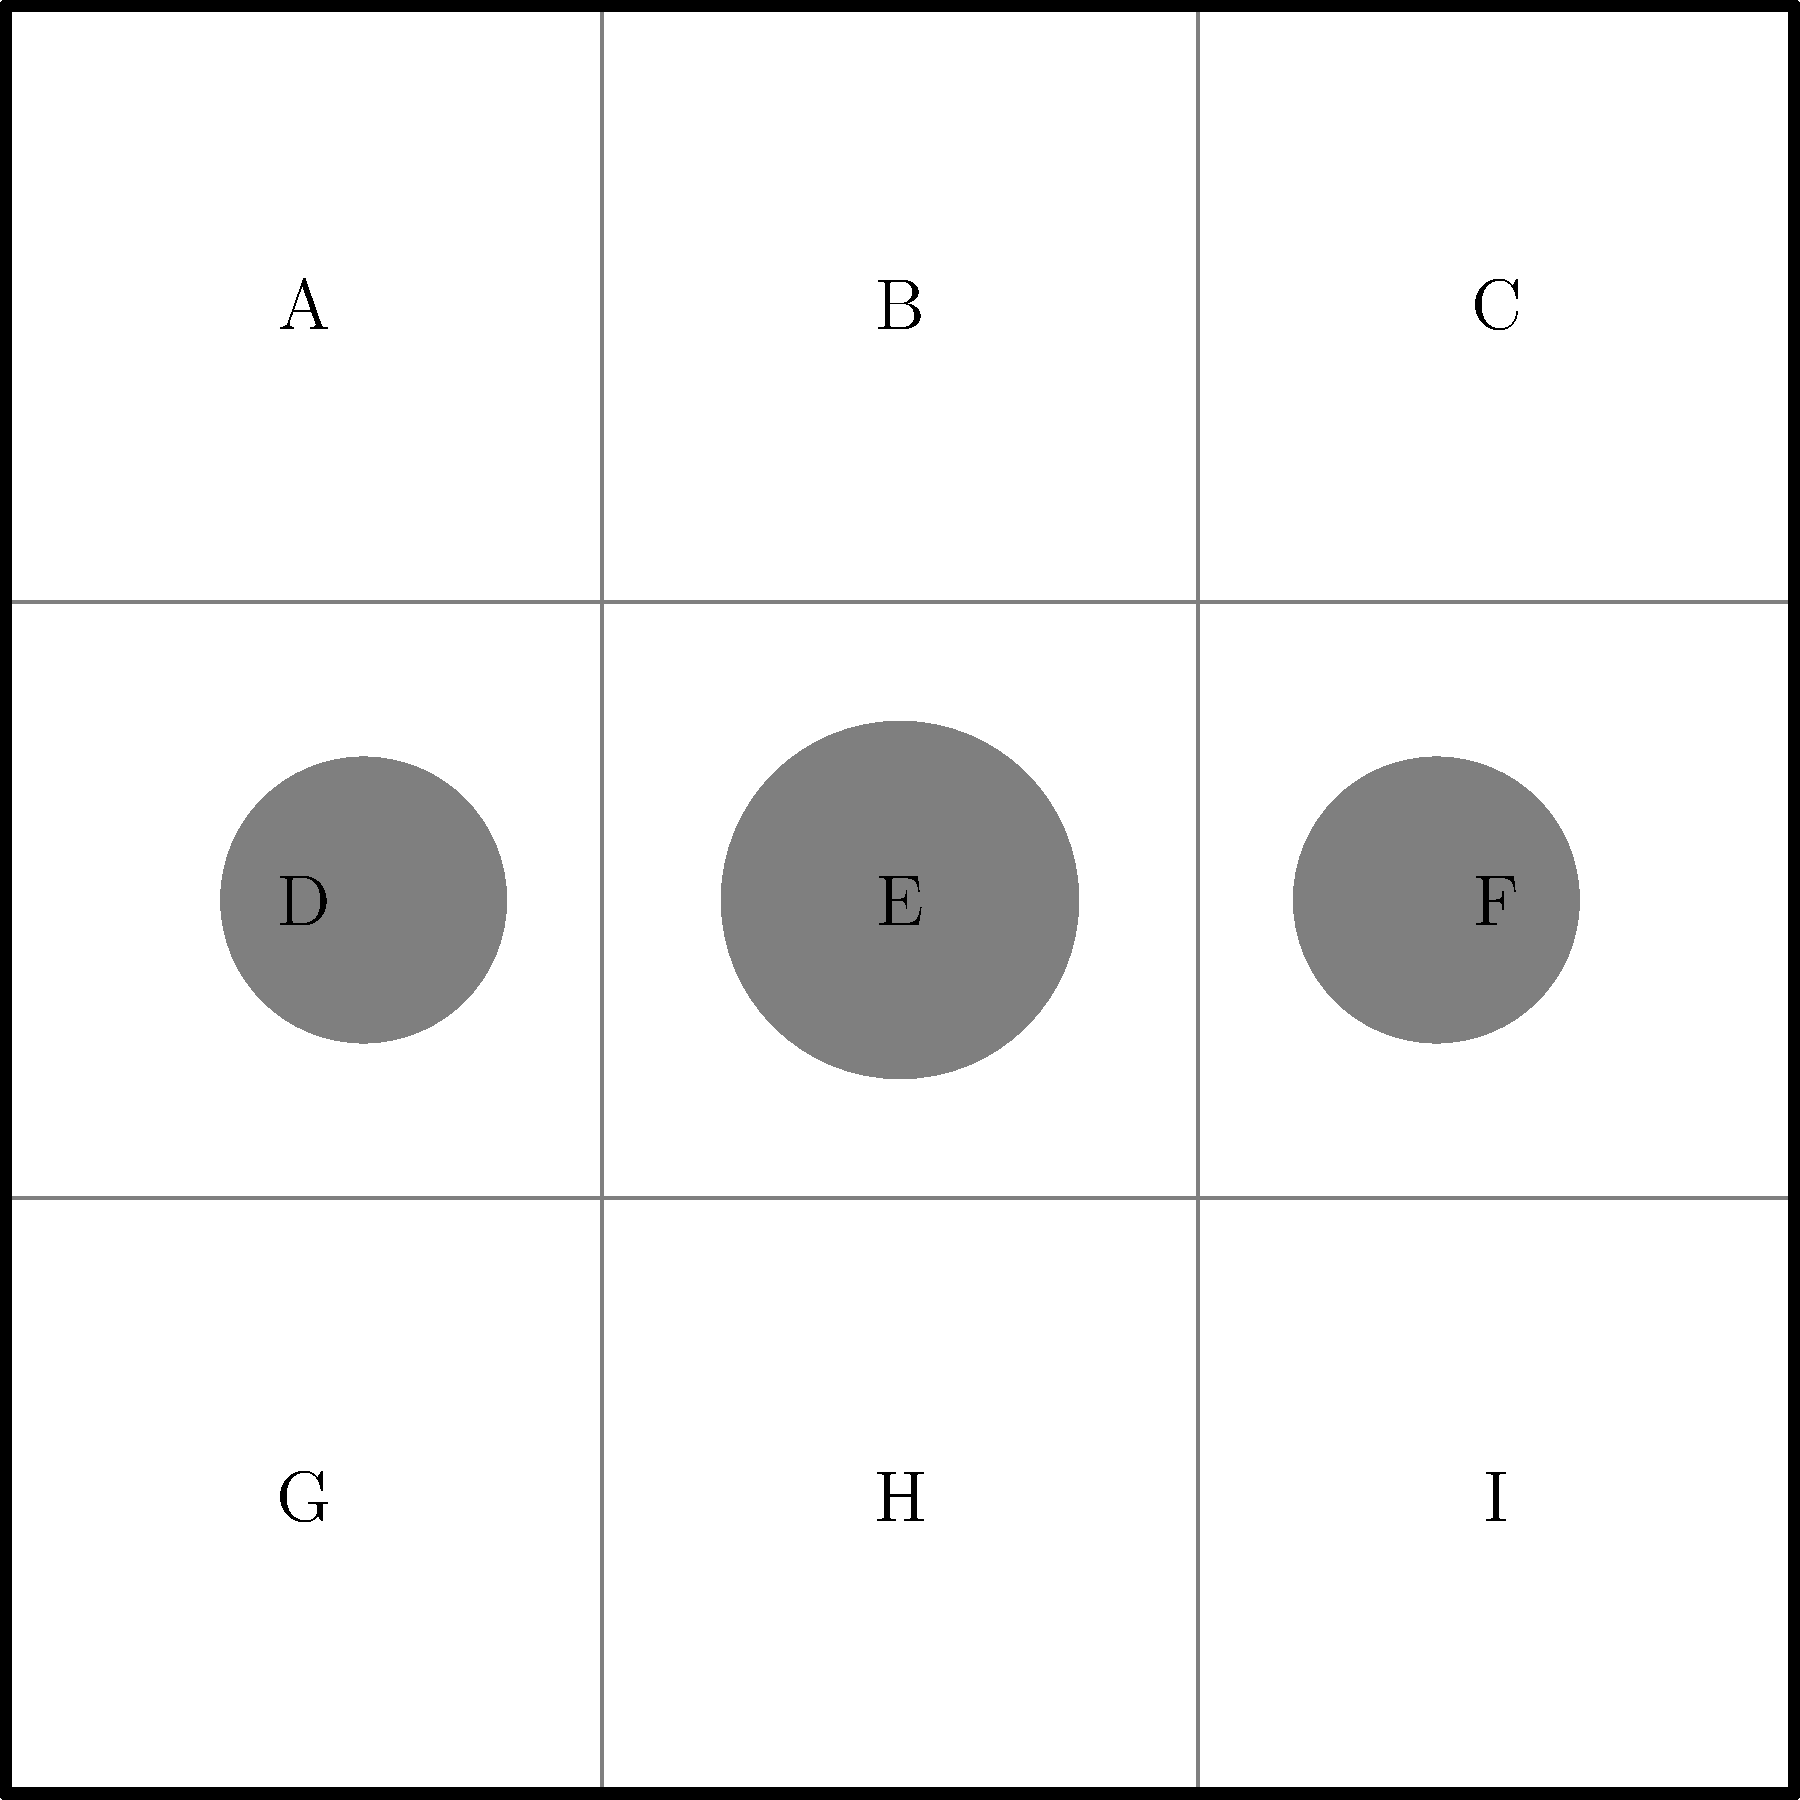Analyze the visual composition of this key frame from a hypothetical Kevin Smith movie using the provided grid overlay. Which grid areas contain the main character, and how does this placement reflect Smith's typical storytelling techniques? 1. The image is divided into a 3x3 grid, labeled A through I.

2. The main character is represented by the larger circle in the center, occupying grid area E.

3. Two supporting characters or elements are shown on either side, in areas D and F.

4. This composition reflects Kevin Smith's storytelling techniques in several ways:
   a) Centrality: The main character is placed in the center (E), emphasizing their importance in the narrative.
   b) Dialogue focus: The arrangement suggests a conversation scene, common in Smith's dialogue-heavy films.
   c) Visual balance: The symmetrical placement of secondary elements creates a balanced frame, allowing focus on character interactions.
   d) Simplicity: The uncluttered composition aligns with Smith's often minimalist visual style, prioritizing character dynamics over complex visuals.

5. This central composition (area E) is frequently used in Smith's films to:
   a) Highlight the protagonist's perspective or internal conflict.
   b) Create a sense of intimacy in conversation scenes.
   c) Draw attention to the character's reactions or emotions.

6. The supporting elements in areas D and F could represent:
   a) Other characters in a dialogue scene.
   b) Environmental elements that contextualize the scene.
   c) Visual metaphors or symbols relevant to the film's themes.

7. This composition technique emphasizes character interactions and dialogue, which are central to Smith's storytelling approach, often exploring themes of friendship, relationships, and personal growth through conversation.
Answer: Area E (center grid), reflecting Smith's focus on character-centric, dialogue-driven storytelling. 